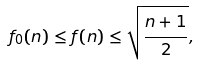Convert formula to latex. <formula><loc_0><loc_0><loc_500><loc_500>f _ { 0 } ( n ) \leq f ( n ) \leq \sqrt { \frac { n + 1 } { 2 } } ,</formula> 